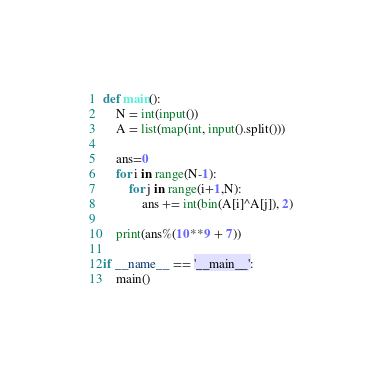<code> <loc_0><loc_0><loc_500><loc_500><_Python_>def main():
    N = int(input())
    A = list(map(int, input().split()))

    ans=0
    for i in range(N-1):
        for j in range(i+1,N):
            ans += int(bin(A[i]^A[j]), 2)

    print(ans%(10**9 + 7))

if __name__ == '__main__':
    main()
</code> 